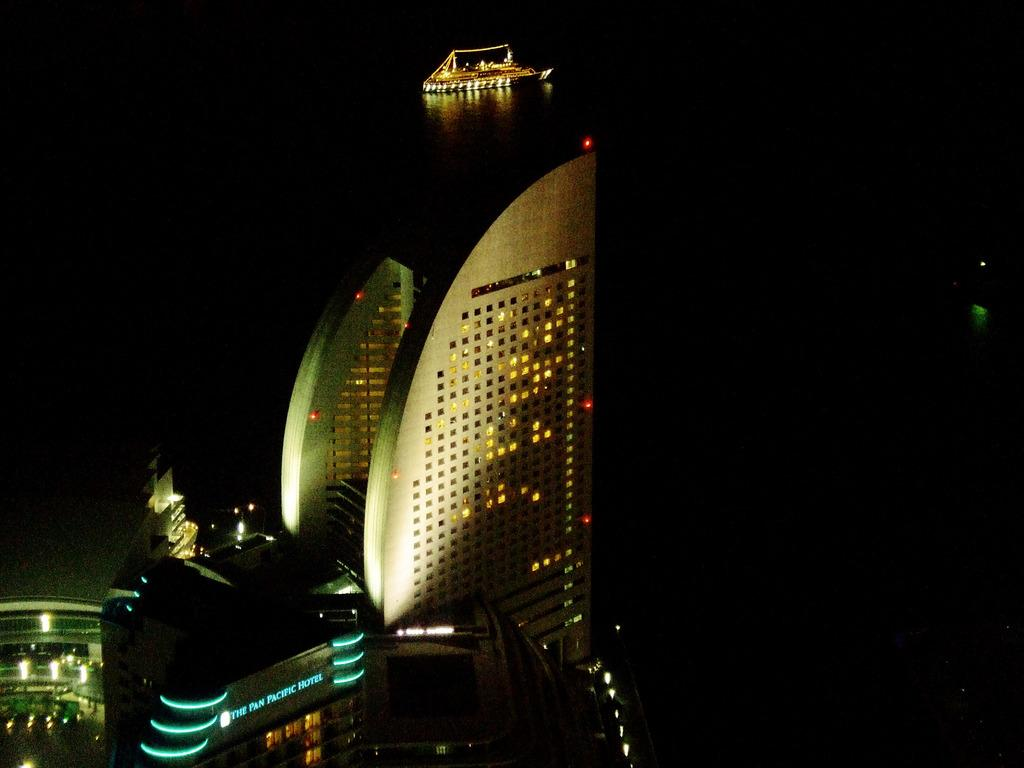<image>
Offer a succinct explanation of the picture presented. The Pan Pacific Hotel at night with a boat in the background. 